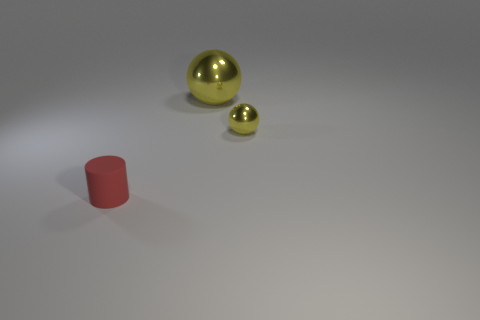Add 3 cyan objects. How many objects exist? 6 Subtract all spheres. How many objects are left? 1 Add 2 matte things. How many matte things exist? 3 Subtract 0 gray cylinders. How many objects are left? 3 Subtract all large spheres. Subtract all large purple rubber cylinders. How many objects are left? 2 Add 3 large yellow spheres. How many large yellow spheres are left? 4 